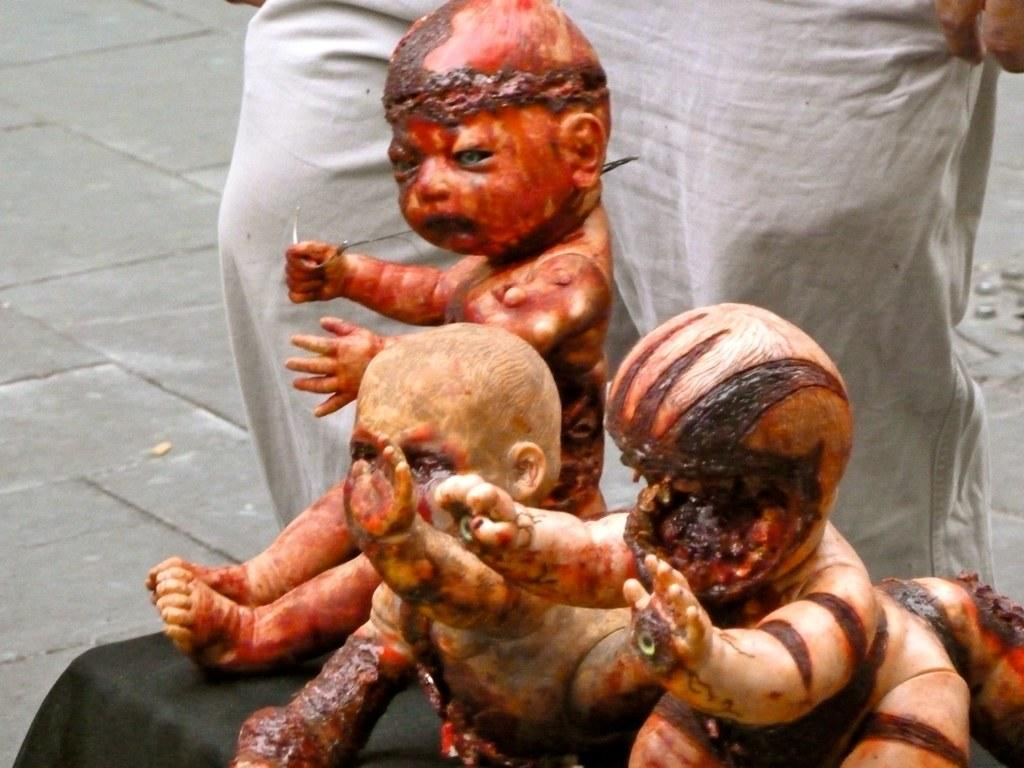What type of toys are featured in the image? There are horror toys in the image. Where are the horror toys placed? The horror toys are kept on a table. Is there a person present in the image? Yes, there is a man standing behind the toys. What is the man's position in relation to the toys? The man is standing behind the toys. What is the man standing on? The man is standing on the ground. What title is written on the calendar in the image? There is no calendar present in the image, so no title can be observed. 